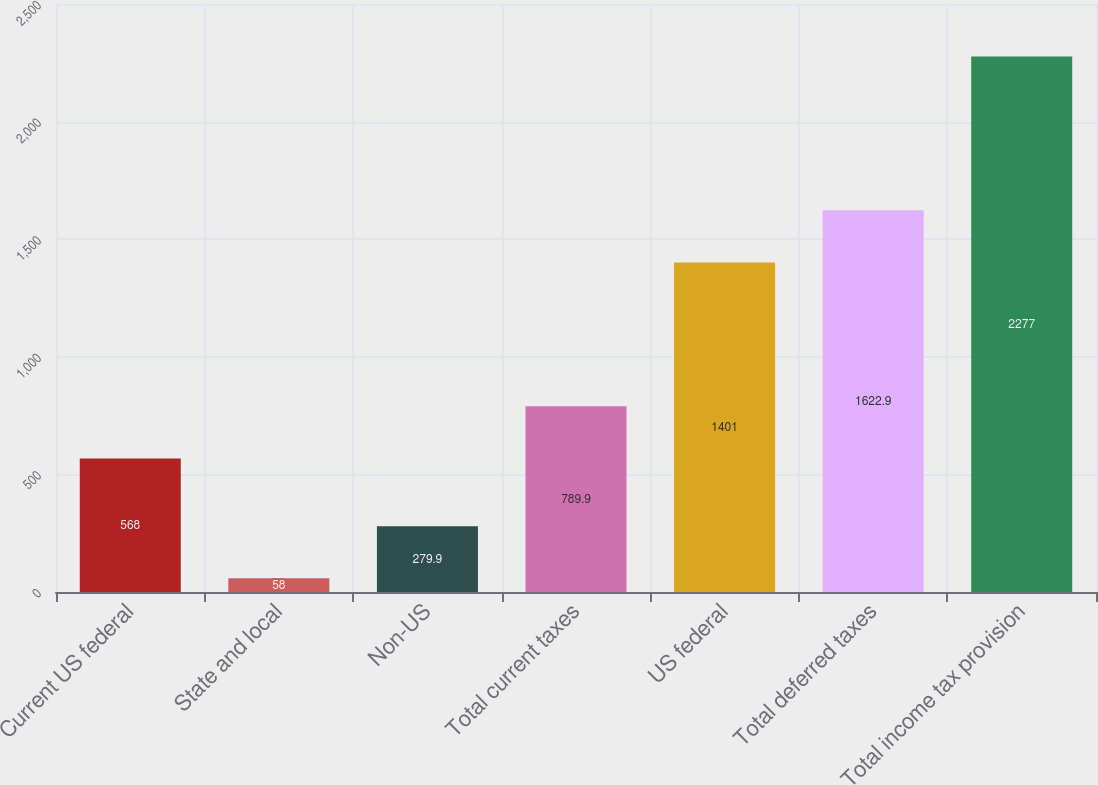<chart> <loc_0><loc_0><loc_500><loc_500><bar_chart><fcel>Current US federal<fcel>State and local<fcel>Non-US<fcel>Total current taxes<fcel>US federal<fcel>Total deferred taxes<fcel>Total income tax provision<nl><fcel>568<fcel>58<fcel>279.9<fcel>789.9<fcel>1401<fcel>1622.9<fcel>2277<nl></chart> 